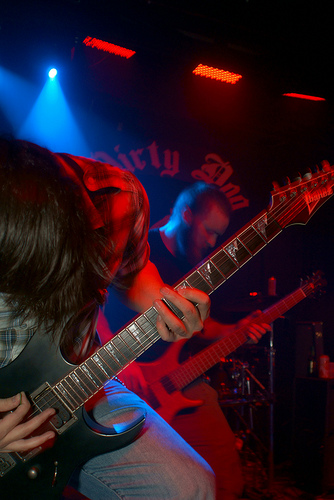<image>
Can you confirm if the lights is above the stage? Yes. The lights is positioned above the stage in the vertical space, higher up in the scene. 